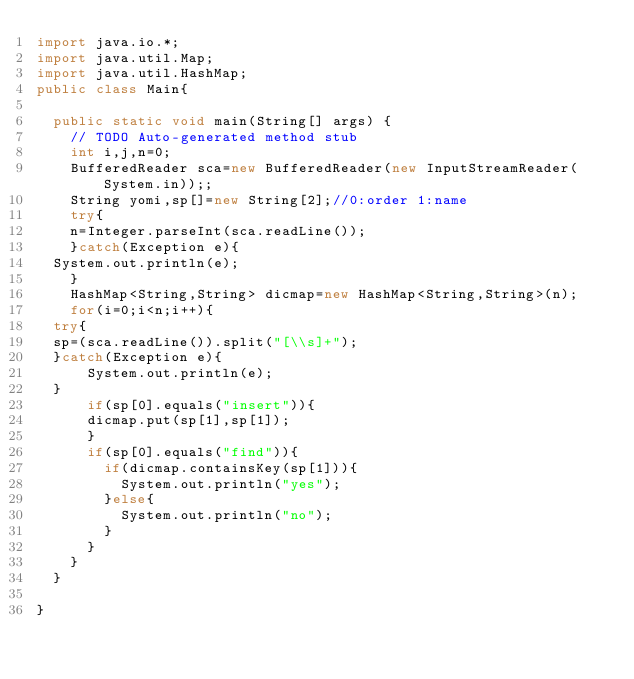Convert code to text. <code><loc_0><loc_0><loc_500><loc_500><_Java_>import java.io.*;
import java.util.Map;
import java.util.HashMap;
public class Main{

	public static void main(String[] args) {
		// TODO Auto-generated method stub
    int i,j,n=0;
    BufferedReader sca=new BufferedReader(new InputStreamReader(System.in));;
    String yomi,sp[]=new String[2];//0:order 1:name
    try{
    n=Integer.parseInt(sca.readLine());
    }catch(Exception e){
	System.out.println(e);
    }
    HashMap<String,String> dicmap=new HashMap<String,String>(n);
    for(i=0;i<n;i++){
	try{
	sp=(sca.readLine()).split("[\\s]+");
	}catch(Exception e){
	    System.out.println(e);
	}
    	if(sp[0].equals("insert")){
	    dicmap.put(sp[1],sp[1]);
    	}
    	if(sp[0].equals("find")){
    		if(dicmap.containsKey(sp[1])){
    			System.out.println("yes");
    		}else{
    			System.out.println("no");
    		}
    	}
    }
	}

}

</code> 